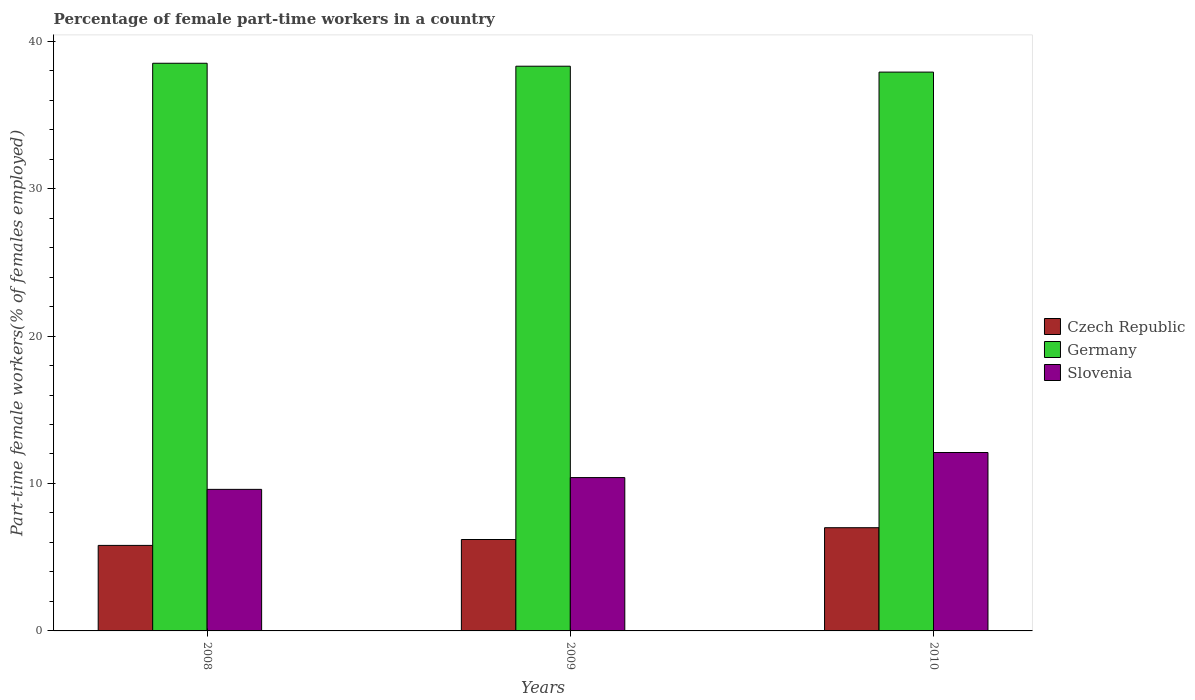How many groups of bars are there?
Keep it short and to the point. 3. How many bars are there on the 2nd tick from the right?
Make the answer very short. 3. What is the label of the 1st group of bars from the left?
Keep it short and to the point. 2008. What is the percentage of female part-time workers in Germany in 2009?
Offer a terse response. 38.3. Across all years, what is the maximum percentage of female part-time workers in Czech Republic?
Make the answer very short. 7. Across all years, what is the minimum percentage of female part-time workers in Slovenia?
Provide a short and direct response. 9.6. In which year was the percentage of female part-time workers in Germany maximum?
Provide a short and direct response. 2008. What is the total percentage of female part-time workers in Slovenia in the graph?
Your answer should be compact. 32.1. What is the difference between the percentage of female part-time workers in Slovenia in 2009 and that in 2010?
Your answer should be very brief. -1.7. What is the difference between the percentage of female part-time workers in Czech Republic in 2010 and the percentage of female part-time workers in Germany in 2009?
Offer a very short reply. -31.3. What is the average percentage of female part-time workers in Germany per year?
Make the answer very short. 38.23. In the year 2008, what is the difference between the percentage of female part-time workers in Germany and percentage of female part-time workers in Slovenia?
Provide a short and direct response. 28.9. In how many years, is the percentage of female part-time workers in Czech Republic greater than 28 %?
Provide a short and direct response. 0. What is the ratio of the percentage of female part-time workers in Czech Republic in 2009 to that in 2010?
Your answer should be very brief. 0.89. What is the difference between the highest and the second highest percentage of female part-time workers in Czech Republic?
Make the answer very short. 0.8. What is the difference between the highest and the lowest percentage of female part-time workers in Czech Republic?
Ensure brevity in your answer.  1.2. Is the sum of the percentage of female part-time workers in Czech Republic in 2009 and 2010 greater than the maximum percentage of female part-time workers in Germany across all years?
Give a very brief answer. No. What does the 3rd bar from the left in 2008 represents?
Offer a very short reply. Slovenia. What does the 3rd bar from the right in 2008 represents?
Keep it short and to the point. Czech Republic. How many bars are there?
Make the answer very short. 9. How many years are there in the graph?
Your answer should be very brief. 3. What is the difference between two consecutive major ticks on the Y-axis?
Your response must be concise. 10. Does the graph contain grids?
Provide a succinct answer. No. Where does the legend appear in the graph?
Keep it short and to the point. Center right. What is the title of the graph?
Offer a very short reply. Percentage of female part-time workers in a country. What is the label or title of the X-axis?
Keep it short and to the point. Years. What is the label or title of the Y-axis?
Give a very brief answer. Part-time female workers(% of females employed). What is the Part-time female workers(% of females employed) in Czech Republic in 2008?
Provide a succinct answer. 5.8. What is the Part-time female workers(% of females employed) in Germany in 2008?
Offer a very short reply. 38.5. What is the Part-time female workers(% of females employed) in Slovenia in 2008?
Provide a short and direct response. 9.6. What is the Part-time female workers(% of females employed) of Czech Republic in 2009?
Give a very brief answer. 6.2. What is the Part-time female workers(% of females employed) of Germany in 2009?
Give a very brief answer. 38.3. What is the Part-time female workers(% of females employed) of Slovenia in 2009?
Give a very brief answer. 10.4. What is the Part-time female workers(% of females employed) of Germany in 2010?
Ensure brevity in your answer.  37.9. What is the Part-time female workers(% of females employed) of Slovenia in 2010?
Your answer should be very brief. 12.1. Across all years, what is the maximum Part-time female workers(% of females employed) in Germany?
Your answer should be very brief. 38.5. Across all years, what is the maximum Part-time female workers(% of females employed) in Slovenia?
Offer a very short reply. 12.1. Across all years, what is the minimum Part-time female workers(% of females employed) of Czech Republic?
Ensure brevity in your answer.  5.8. Across all years, what is the minimum Part-time female workers(% of females employed) of Germany?
Offer a very short reply. 37.9. Across all years, what is the minimum Part-time female workers(% of females employed) in Slovenia?
Give a very brief answer. 9.6. What is the total Part-time female workers(% of females employed) in Czech Republic in the graph?
Your answer should be very brief. 19. What is the total Part-time female workers(% of females employed) in Germany in the graph?
Offer a terse response. 114.7. What is the total Part-time female workers(% of females employed) in Slovenia in the graph?
Your response must be concise. 32.1. What is the difference between the Part-time female workers(% of females employed) of Czech Republic in 2008 and that in 2009?
Provide a short and direct response. -0.4. What is the difference between the Part-time female workers(% of females employed) of Slovenia in 2008 and that in 2009?
Your response must be concise. -0.8. What is the difference between the Part-time female workers(% of females employed) in Germany in 2008 and that in 2010?
Offer a terse response. 0.6. What is the difference between the Part-time female workers(% of females employed) in Slovenia in 2008 and that in 2010?
Your answer should be compact. -2.5. What is the difference between the Part-time female workers(% of females employed) of Slovenia in 2009 and that in 2010?
Offer a very short reply. -1.7. What is the difference between the Part-time female workers(% of females employed) of Czech Republic in 2008 and the Part-time female workers(% of females employed) of Germany in 2009?
Offer a terse response. -32.5. What is the difference between the Part-time female workers(% of females employed) of Germany in 2008 and the Part-time female workers(% of females employed) of Slovenia in 2009?
Give a very brief answer. 28.1. What is the difference between the Part-time female workers(% of females employed) in Czech Republic in 2008 and the Part-time female workers(% of females employed) in Germany in 2010?
Give a very brief answer. -32.1. What is the difference between the Part-time female workers(% of females employed) of Germany in 2008 and the Part-time female workers(% of females employed) of Slovenia in 2010?
Your answer should be very brief. 26.4. What is the difference between the Part-time female workers(% of females employed) in Czech Republic in 2009 and the Part-time female workers(% of females employed) in Germany in 2010?
Your answer should be compact. -31.7. What is the difference between the Part-time female workers(% of females employed) of Germany in 2009 and the Part-time female workers(% of females employed) of Slovenia in 2010?
Your answer should be compact. 26.2. What is the average Part-time female workers(% of females employed) in Czech Republic per year?
Offer a very short reply. 6.33. What is the average Part-time female workers(% of females employed) of Germany per year?
Offer a terse response. 38.23. What is the average Part-time female workers(% of females employed) in Slovenia per year?
Ensure brevity in your answer.  10.7. In the year 2008, what is the difference between the Part-time female workers(% of females employed) in Czech Republic and Part-time female workers(% of females employed) in Germany?
Your response must be concise. -32.7. In the year 2008, what is the difference between the Part-time female workers(% of females employed) in Germany and Part-time female workers(% of females employed) in Slovenia?
Provide a short and direct response. 28.9. In the year 2009, what is the difference between the Part-time female workers(% of females employed) of Czech Republic and Part-time female workers(% of females employed) of Germany?
Your response must be concise. -32.1. In the year 2009, what is the difference between the Part-time female workers(% of females employed) of Germany and Part-time female workers(% of females employed) of Slovenia?
Provide a succinct answer. 27.9. In the year 2010, what is the difference between the Part-time female workers(% of females employed) in Czech Republic and Part-time female workers(% of females employed) in Germany?
Provide a succinct answer. -30.9. In the year 2010, what is the difference between the Part-time female workers(% of females employed) of Czech Republic and Part-time female workers(% of females employed) of Slovenia?
Make the answer very short. -5.1. In the year 2010, what is the difference between the Part-time female workers(% of females employed) of Germany and Part-time female workers(% of females employed) of Slovenia?
Provide a short and direct response. 25.8. What is the ratio of the Part-time female workers(% of females employed) in Czech Republic in 2008 to that in 2009?
Provide a succinct answer. 0.94. What is the ratio of the Part-time female workers(% of females employed) of Slovenia in 2008 to that in 2009?
Make the answer very short. 0.92. What is the ratio of the Part-time female workers(% of females employed) of Czech Republic in 2008 to that in 2010?
Make the answer very short. 0.83. What is the ratio of the Part-time female workers(% of females employed) of Germany in 2008 to that in 2010?
Provide a short and direct response. 1.02. What is the ratio of the Part-time female workers(% of females employed) of Slovenia in 2008 to that in 2010?
Your answer should be very brief. 0.79. What is the ratio of the Part-time female workers(% of females employed) in Czech Republic in 2009 to that in 2010?
Offer a very short reply. 0.89. What is the ratio of the Part-time female workers(% of females employed) of Germany in 2009 to that in 2010?
Make the answer very short. 1.01. What is the ratio of the Part-time female workers(% of females employed) of Slovenia in 2009 to that in 2010?
Keep it short and to the point. 0.86. What is the difference between the highest and the second highest Part-time female workers(% of females employed) of Germany?
Your answer should be very brief. 0.2. What is the difference between the highest and the second highest Part-time female workers(% of females employed) of Slovenia?
Offer a very short reply. 1.7. What is the difference between the highest and the lowest Part-time female workers(% of females employed) in Germany?
Provide a succinct answer. 0.6. 